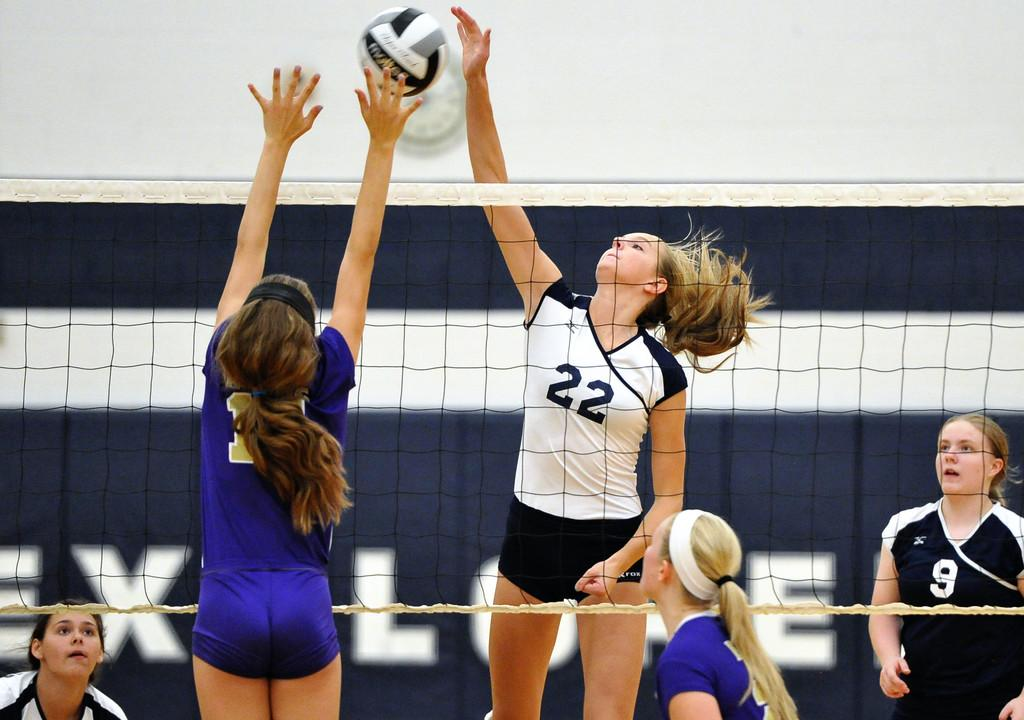Provide a one-sentence caption for the provided image. A girl volleyball player in blue uniform attempts to block a spike by no 22 in a white uniform. 